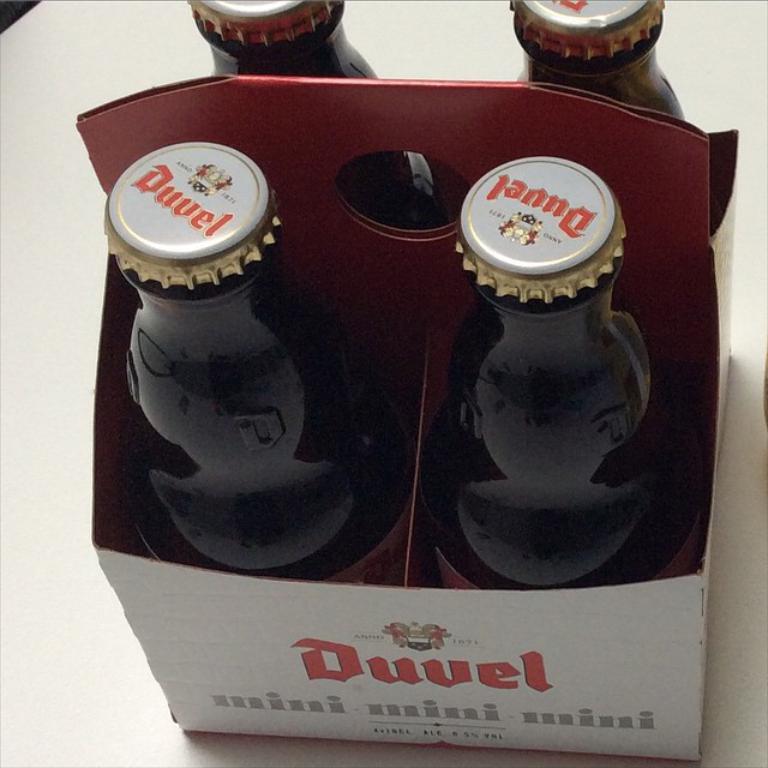Are these mini?
Offer a terse response. Yes. 